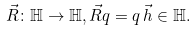<formula> <loc_0><loc_0><loc_500><loc_500>\vec { R } \colon \mathbb { H } \rightarrow \mathbb { H } , \vec { R } q = q \, \vec { h } \in \mathbb { H } .</formula> 